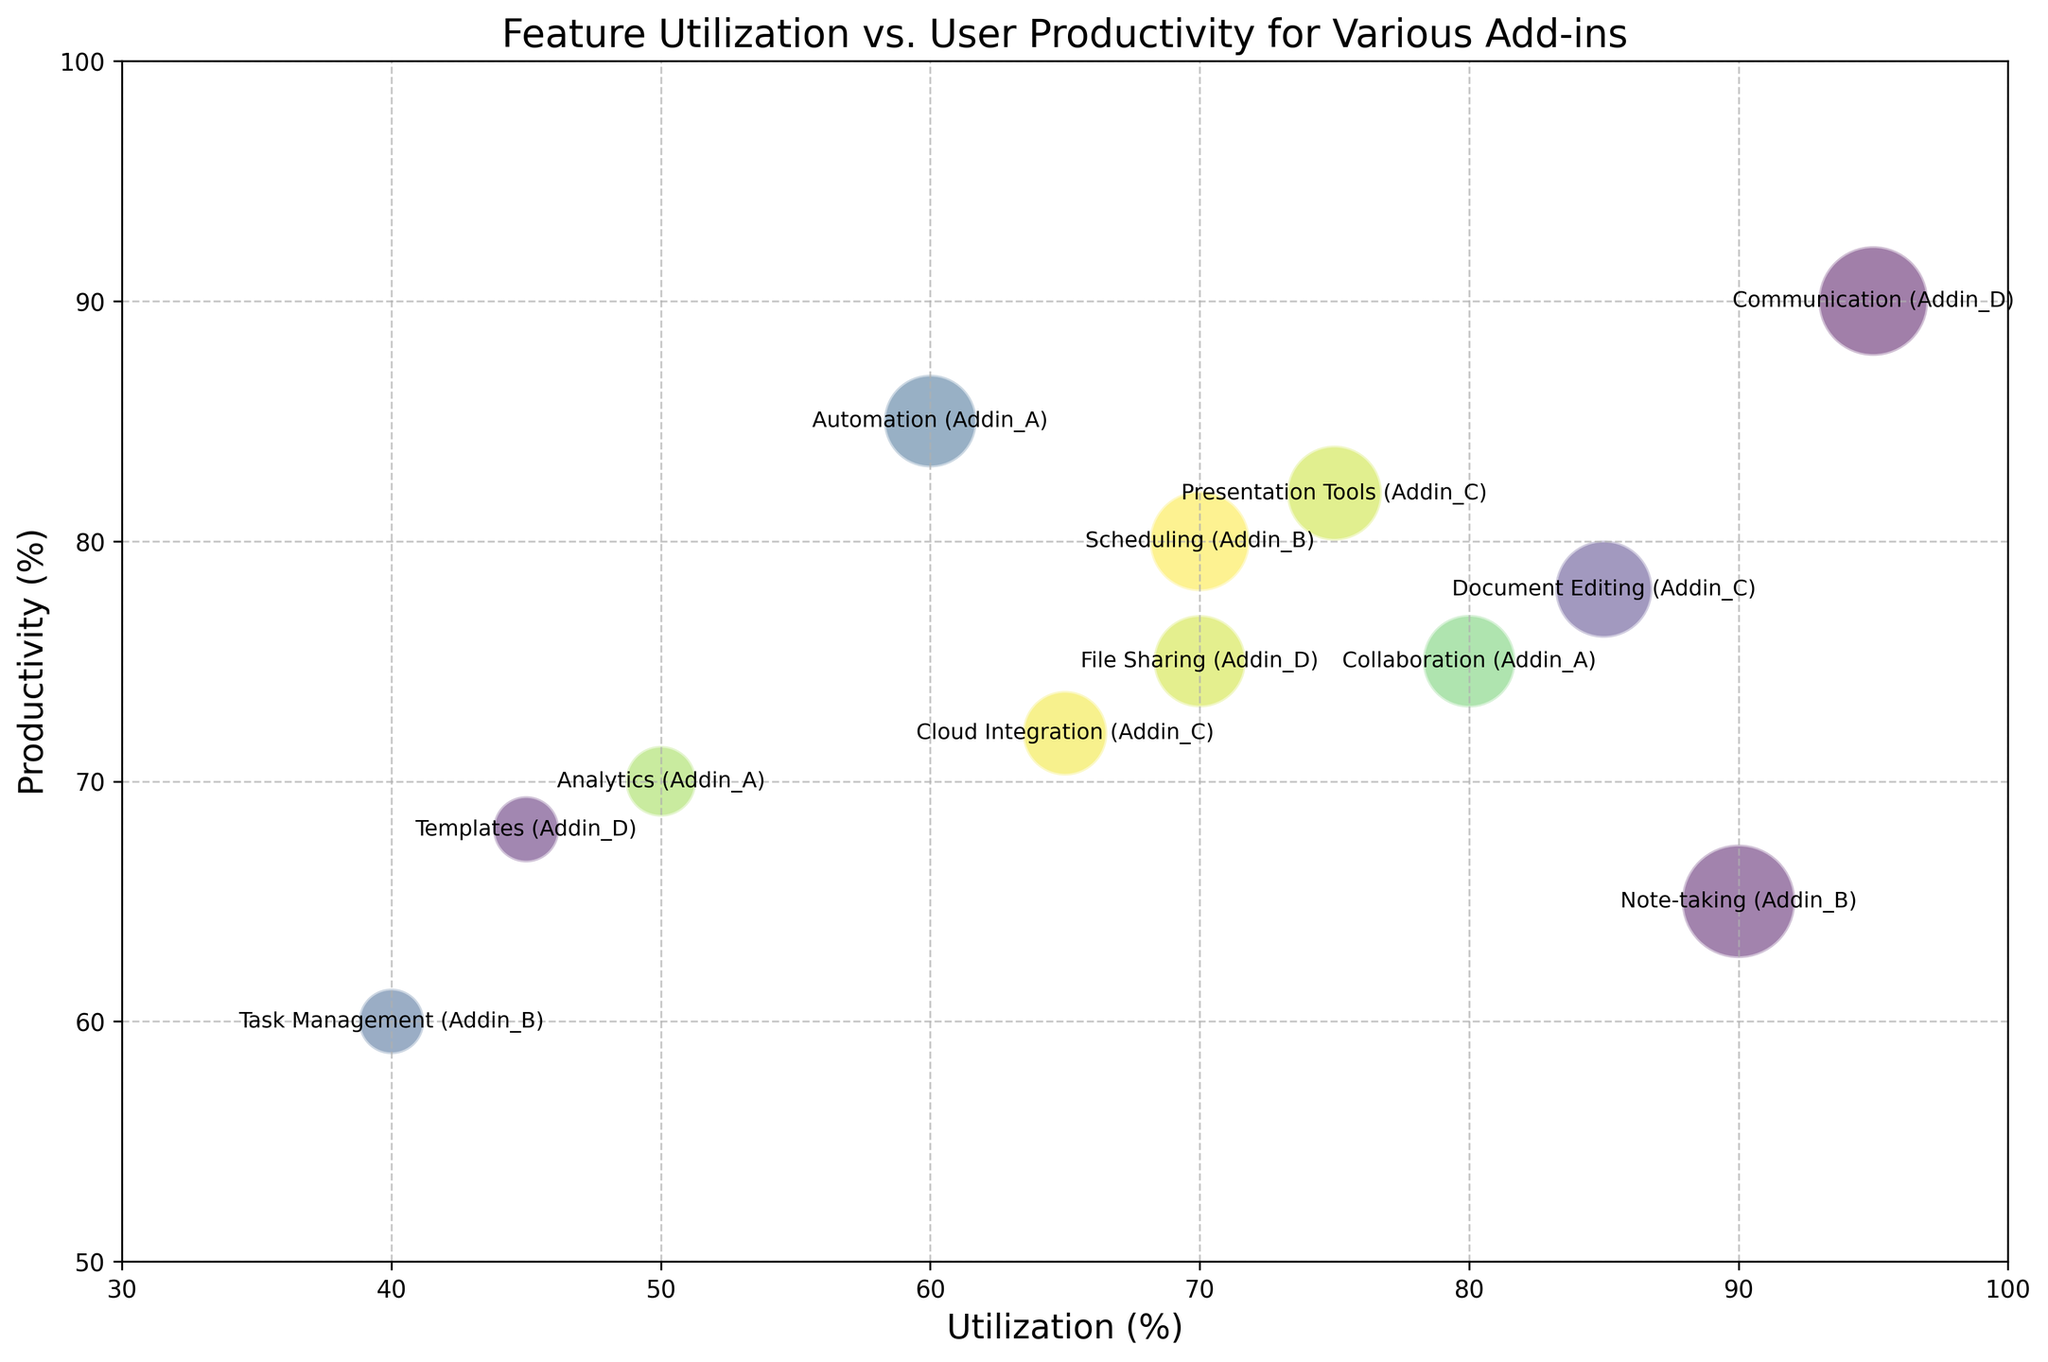What is the add-in with the highest productivity? The add-in with the highest productivity can be found by looking at the bubble with the highest y-axis value. In this case, the highest productivity (90%) is for Addin_D with the Communication feature.
Answer: Communication (Addin_D) Which feature-addin pair has the largest bubble? The size of the bubbles represents the impact. The largest bubble indicates the highest impact, which can be identified by observing the plot. The Note-taking feature for Addin_B has the largest bubble size, representing an impact of 4500.
Answer: Note-taking (Addin_B) Is there any add-in that has both a high utilization and high productivity score? To identify an add-in with both high utilization and high productivity, we need to look for bubbles in the top-right quadrant of the chart. The Communication feature of Addin_D has a utilization of 95% and productivity of 90%, making it both high utilization and high productivity.
Answer: Communication (Addin_D) What is the average impact of Addin_A features? Addin_A has three features: Collaboration, Automation, and Analytics with impacts of 3000, 3000, and 1750 respectively. The average impact is calculated by (3000 + 3000 + 1750) / 3 = 7750 / 3.
Answer: 2583.33 Compare the utilization between the Scheduling feature of Addin_B and the Presentation Tools feature of Addin_C. Which one is higher? The utilization of the Scheduling feature of Addin_B is 70%, whereas the utilization of the Presentation Tools feature of Addin_C is 75%. Hence, the utilization of Presentation Tools (Addin_C) is higher.
Answer: Presentation Tools (Addin_C) Which add-in has the lowest productivity score? The add-in with the lowest productivity score can be found by observing the bubble with the lowest position on the y-axis. The Task Management feature of Addin_B has the lowest productivity score of 60%.
Answer: Task Management (Addin_B) How does the impact of Document Editing by Addin_C compare to File Sharing by Addin_D? The impact of Document Editing by Addin_C is 3300, while the impact of File Sharing by Addin_D is 2975. Document Editing by Addin_C has a higher impact compared to File Sharing by Addin_D.
Answer: Document Editing (Addin_C) Which features in Addin_D have higher than 70% productivity? To find features in Addin_D with higher than 70% productivity, we look for bubbles with 'Addin_D' and check if their y-axis values exceed 70%. There are Communication (90%), File Sharing (75%), and Templates (68%). Hence, Communication and File Sharing are above 70%.
Answer: Communication, File Sharing 